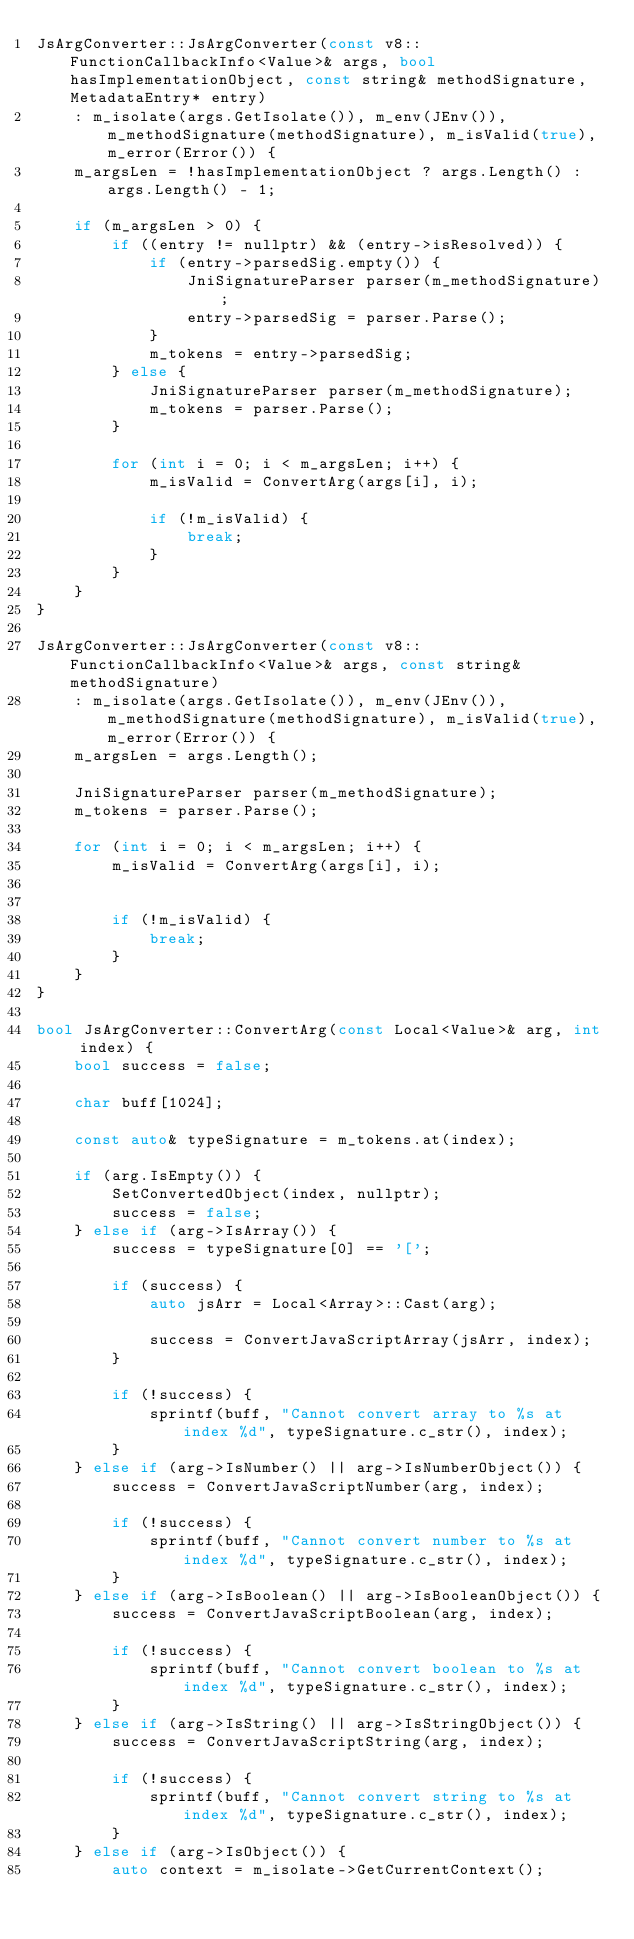<code> <loc_0><loc_0><loc_500><loc_500><_C++_>JsArgConverter::JsArgConverter(const v8::FunctionCallbackInfo<Value>& args, bool hasImplementationObject, const string& methodSignature, MetadataEntry* entry)
    : m_isolate(args.GetIsolate()), m_env(JEnv()), m_methodSignature(methodSignature), m_isValid(true), m_error(Error()) {
    m_argsLen = !hasImplementationObject ? args.Length() : args.Length() - 1;

    if (m_argsLen > 0) {
        if ((entry != nullptr) && (entry->isResolved)) {
            if (entry->parsedSig.empty()) {
                JniSignatureParser parser(m_methodSignature);
                entry->parsedSig = parser.Parse();
            }
            m_tokens = entry->parsedSig;
        } else {
            JniSignatureParser parser(m_methodSignature);
            m_tokens = parser.Parse();
        }

        for (int i = 0; i < m_argsLen; i++) {
            m_isValid = ConvertArg(args[i], i);

            if (!m_isValid) {
                break;
            }
        }
    }
}

JsArgConverter::JsArgConverter(const v8::FunctionCallbackInfo<Value>& args, const string& methodSignature)
    : m_isolate(args.GetIsolate()), m_env(JEnv()), m_methodSignature(methodSignature), m_isValid(true), m_error(Error()) {
    m_argsLen = args.Length();

    JniSignatureParser parser(m_methodSignature);
    m_tokens = parser.Parse();

    for (int i = 0; i < m_argsLen; i++) {
        m_isValid = ConvertArg(args[i], i);


        if (!m_isValid) {
            break;
        }
    }
}

bool JsArgConverter::ConvertArg(const Local<Value>& arg, int index) {
    bool success = false;

    char buff[1024];

    const auto& typeSignature = m_tokens.at(index);

    if (arg.IsEmpty()) {
        SetConvertedObject(index, nullptr);
        success = false;
    } else if (arg->IsArray()) {
        success = typeSignature[0] == '[';

        if (success) {
            auto jsArr = Local<Array>::Cast(arg);

            success = ConvertJavaScriptArray(jsArr, index);
        }

        if (!success) {
            sprintf(buff, "Cannot convert array to %s at index %d", typeSignature.c_str(), index);
        }
    } else if (arg->IsNumber() || arg->IsNumberObject()) {
        success = ConvertJavaScriptNumber(arg, index);

        if (!success) {
            sprintf(buff, "Cannot convert number to %s at index %d", typeSignature.c_str(), index);
        }
    } else if (arg->IsBoolean() || arg->IsBooleanObject()) {
        success = ConvertJavaScriptBoolean(arg, index);

        if (!success) {
            sprintf(buff, "Cannot convert boolean to %s at index %d", typeSignature.c_str(), index);
        }
    } else if (arg->IsString() || arg->IsStringObject()) {
        success = ConvertJavaScriptString(arg, index);

        if (!success) {
            sprintf(buff, "Cannot convert string to %s at index %d", typeSignature.c_str(), index);
        }
    } else if (arg->IsObject()) {
        auto context = m_isolate->GetCurrentContext();</code> 